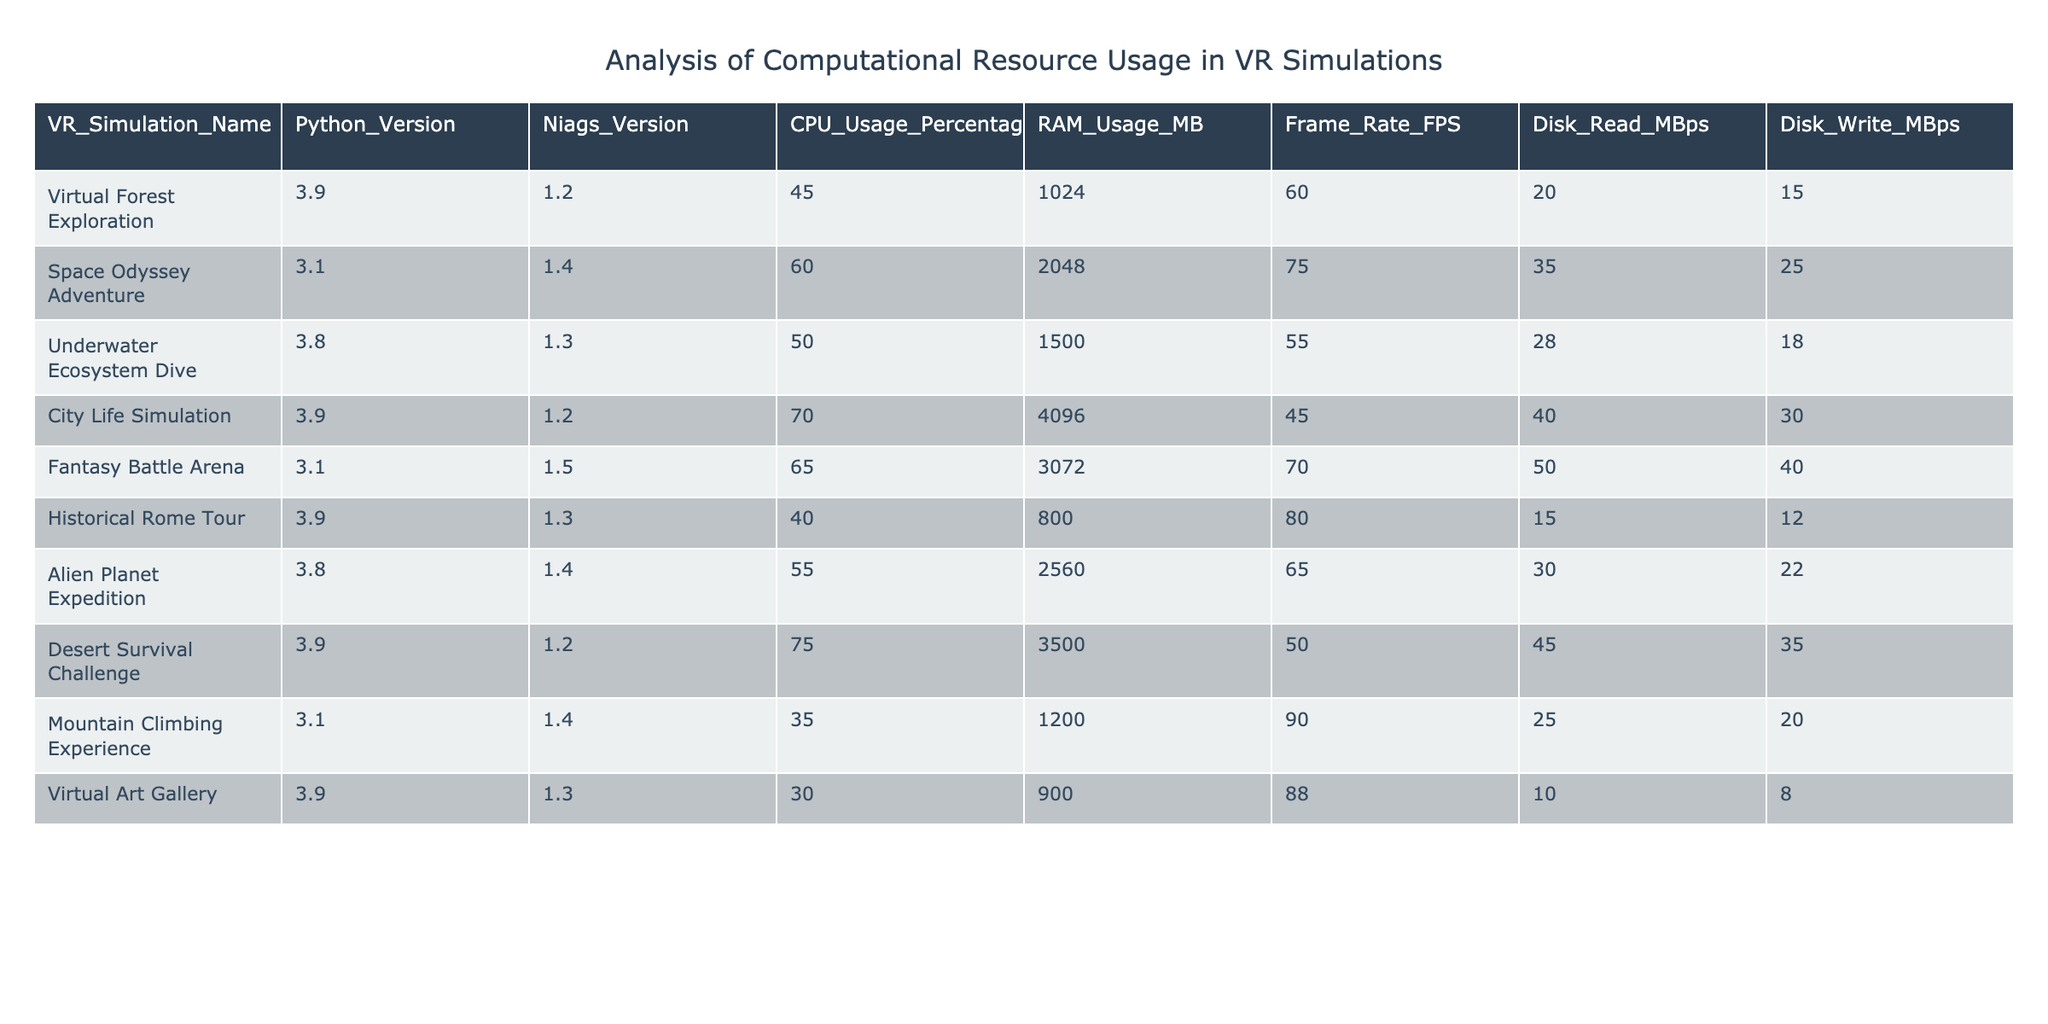What is the CPU usage percentage of the "Virtual Forest Exploration" simulation? The table explicitly lists the CPU usage percentage of the "Virtual Forest Exploration" simulation in the corresponding row. It's shown as 45.
Answer: 45 What simulation has the highest RAM usage? By examining the RAM usage column, we find that the "City Life Simulation" has the highest RAM usage listed at 4096 MB.
Answer: City Life Simulation What is the average frame rate of all simulations? We sum the frame rates: (60 + 75 + 55 + 45 + 70 + 80 + 65 + 50 + 90 + 88) = 775. There are 10 simulations, so the average is 775/10 = 77.5.
Answer: 77.5 Does the "Fantasy Battle Arena" simulation have a higher disk write speed than the "Historical Rome Tour"? Comparing the disk write speeds, "Fantasy Battle Arena" has 40 MBps while "Historical Rome Tour" has 12 MBps. Since 40 is greater than 12, the answer is yes.
Answer: Yes What is the difference in CPU usage percentage between the "Desert Survival Challenge" and "Mountain Climbing Experience"? The CPU usage for "Desert Survival Challenge" is 75% and for "Mountain Climbing Experience" it is 35%. The difference is 75 - 35 = 40.
Answer: 40 Which simulation has a higher frame rate, the "Alien Planet Expedition" or "Underwater Ecosystem Dive"? The frame rate of "Alien Planet Expedition" is 65 FPS, and "Underwater Ecosystem Dive" is 55 FPS. Since 65 is greater than 55, the answer is "Alien Planet Expedition."
Answer: Alien Planet Expedition Is there a simulation that uses less than 1000 MB of RAM? Checking the RAM usage values, "Historical Rome Tour" has 800 MB, which is less than 1000 MB. Therefore, the answer is yes.
Answer: Yes What is the median CPU usage percentage of all simulations? To find the median, we first list the CPU usage percentages in ascending order: 30, 35, 40, 45, 50, 55, 60, 65, 70, 75. With 10 values, the median is the average of the 5th and 6th values: (50 + 55) / 2 = 52.5.
Answer: 52.5 Can you identify any simulation that utilizes more than 2000 MB of RAM? Looking at the RAM usage column, "Space Odyssey Adventure" (2048 MB), "City Life Simulation" (4096 MB), and "Desert Survival Challenge" (3500 MB) all exceed 2000 MB. Therefore, the answer is yes.
Answer: Yes 